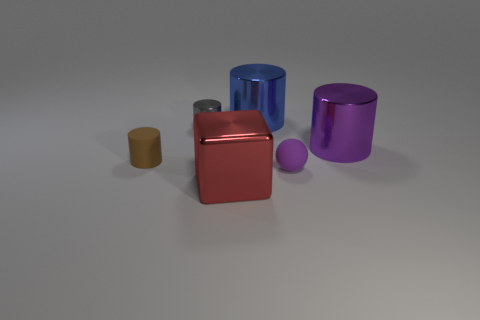Subtract 1 cylinders. How many cylinders are left? 3 Subtract all brown spheres. Subtract all red cylinders. How many spheres are left? 1 Add 1 tiny purple rubber spheres. How many objects exist? 7 Subtract all cubes. How many objects are left? 5 Subtract all yellow objects. Subtract all purple objects. How many objects are left? 4 Add 4 large purple cylinders. How many large purple cylinders are left? 5 Add 6 matte balls. How many matte balls exist? 7 Subtract 0 cyan blocks. How many objects are left? 6 